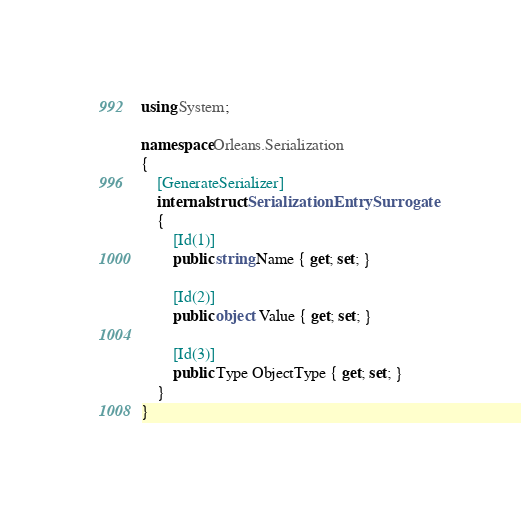Convert code to text. <code><loc_0><loc_0><loc_500><loc_500><_C#_>using System;

namespace Orleans.Serialization
{
    [GenerateSerializer]
    internal struct SerializationEntrySurrogate
    {
        [Id(1)]
        public string Name { get; set; }

        [Id(2)]
        public object Value { get; set; }

        [Id(3)]
        public Type ObjectType { get; set; }
    }
}</code> 